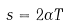<formula> <loc_0><loc_0><loc_500><loc_500>s = 2 \alpha T</formula> 